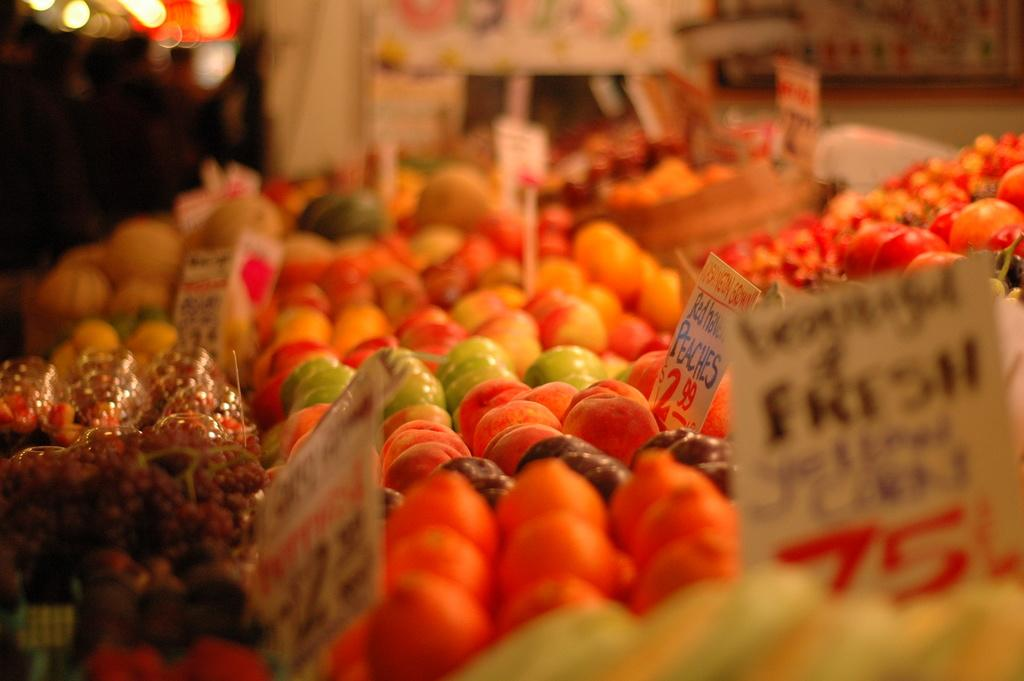What types of food items are present in the image? There are many fruits in the image. What else can be seen in the image besides the fruits? There are boards with text in the image. Can you describe the background of the image? The background of the image is blurry. What type of bird can be seen reading the boards in the image? There is no bird present in the image, let alone one that is reading the boards. 